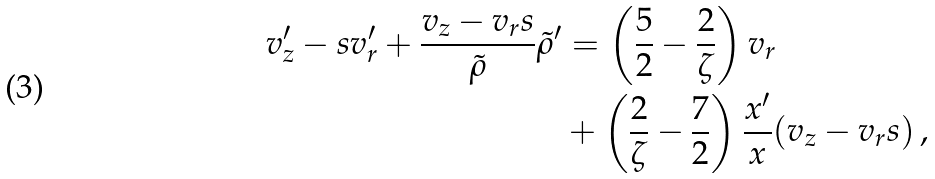Convert formula to latex. <formula><loc_0><loc_0><loc_500><loc_500>v _ { z } ^ { \prime } - s v _ { r } ^ { \prime } + \frac { v _ { z } - v _ { r } s } { \tilde { \rho } } \tilde { \rho } ^ { \prime } & = \left ( \frac { 5 } { 2 } - \frac { 2 } { \zeta } \right ) v _ { r } \\ & + \left ( \frac { 2 } { \zeta } - \frac { 7 } { 2 } \right ) \frac { x ^ { \prime } } { x } ( v _ { z } - v _ { r } s ) \, ,</formula> 